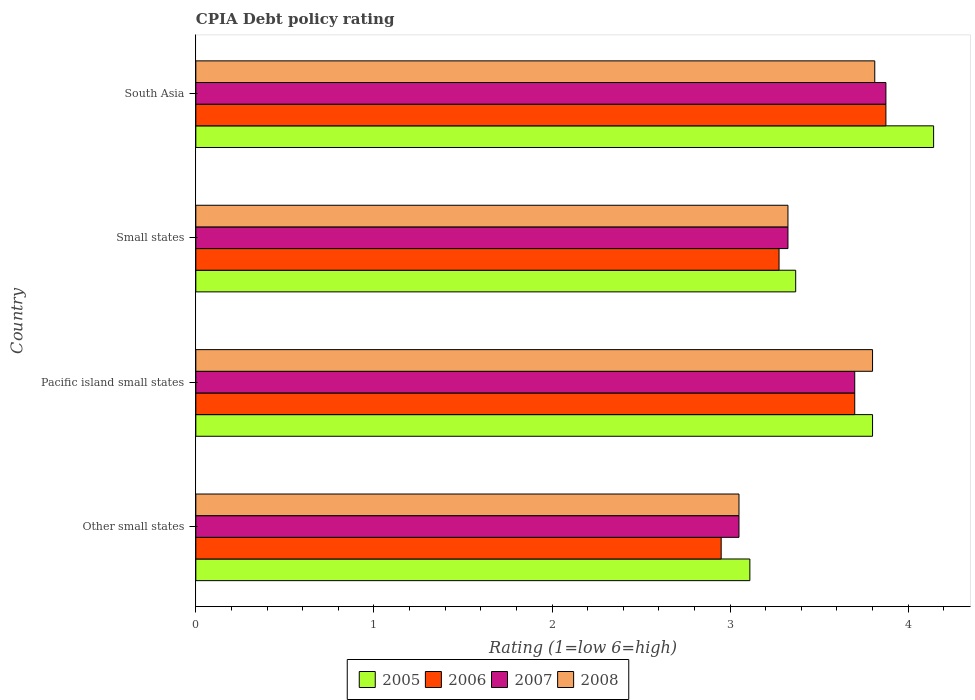How many different coloured bars are there?
Offer a very short reply. 4. How many groups of bars are there?
Your answer should be very brief. 4. Are the number of bars per tick equal to the number of legend labels?
Offer a very short reply. Yes. Are the number of bars on each tick of the Y-axis equal?
Keep it short and to the point. Yes. How many bars are there on the 2nd tick from the top?
Keep it short and to the point. 4. How many bars are there on the 2nd tick from the bottom?
Offer a very short reply. 4. What is the label of the 4th group of bars from the top?
Give a very brief answer. Other small states. In how many cases, is the number of bars for a given country not equal to the number of legend labels?
Your response must be concise. 0. What is the CPIA rating in 2008 in Small states?
Give a very brief answer. 3.33. Across all countries, what is the maximum CPIA rating in 2007?
Give a very brief answer. 3.88. Across all countries, what is the minimum CPIA rating in 2008?
Your response must be concise. 3.05. In which country was the CPIA rating in 2005 minimum?
Your answer should be very brief. Other small states. What is the difference between the CPIA rating in 2005 in Other small states and that in Pacific island small states?
Offer a terse response. -0.69. What is the difference between the CPIA rating in 2008 in Pacific island small states and the CPIA rating in 2005 in Small states?
Your answer should be compact. 0.43. What is the average CPIA rating in 2006 per country?
Offer a terse response. 3.45. What is the difference between the CPIA rating in 2005 and CPIA rating in 2006 in Pacific island small states?
Provide a short and direct response. 0.1. What is the ratio of the CPIA rating in 2007 in Other small states to that in Small states?
Provide a succinct answer. 0.92. Is the difference between the CPIA rating in 2005 in Small states and South Asia greater than the difference between the CPIA rating in 2006 in Small states and South Asia?
Your answer should be very brief. No. What is the difference between the highest and the second highest CPIA rating in 2008?
Offer a very short reply. 0.01. What is the difference between the highest and the lowest CPIA rating in 2007?
Your answer should be very brief. 0.83. What does the 2nd bar from the bottom in Pacific island small states represents?
Your response must be concise. 2006. What is the difference between two consecutive major ticks on the X-axis?
Offer a terse response. 1. Are the values on the major ticks of X-axis written in scientific E-notation?
Provide a short and direct response. No. Does the graph contain grids?
Your answer should be compact. No. How are the legend labels stacked?
Keep it short and to the point. Horizontal. What is the title of the graph?
Give a very brief answer. CPIA Debt policy rating. What is the label or title of the X-axis?
Your response must be concise. Rating (1=low 6=high). What is the label or title of the Y-axis?
Ensure brevity in your answer.  Country. What is the Rating (1=low 6=high) in 2005 in Other small states?
Your answer should be compact. 3.11. What is the Rating (1=low 6=high) of 2006 in Other small states?
Offer a very short reply. 2.95. What is the Rating (1=low 6=high) in 2007 in Other small states?
Make the answer very short. 3.05. What is the Rating (1=low 6=high) in 2008 in Other small states?
Offer a terse response. 3.05. What is the Rating (1=low 6=high) in 2006 in Pacific island small states?
Your answer should be compact. 3.7. What is the Rating (1=low 6=high) of 2008 in Pacific island small states?
Your answer should be very brief. 3.8. What is the Rating (1=low 6=high) in 2005 in Small states?
Provide a short and direct response. 3.37. What is the Rating (1=low 6=high) in 2006 in Small states?
Provide a succinct answer. 3.27. What is the Rating (1=low 6=high) of 2007 in Small states?
Make the answer very short. 3.33. What is the Rating (1=low 6=high) in 2008 in Small states?
Your response must be concise. 3.33. What is the Rating (1=low 6=high) in 2005 in South Asia?
Your response must be concise. 4.14. What is the Rating (1=low 6=high) of 2006 in South Asia?
Offer a very short reply. 3.88. What is the Rating (1=low 6=high) of 2007 in South Asia?
Offer a very short reply. 3.88. What is the Rating (1=low 6=high) in 2008 in South Asia?
Your answer should be compact. 3.81. Across all countries, what is the maximum Rating (1=low 6=high) in 2005?
Your answer should be compact. 4.14. Across all countries, what is the maximum Rating (1=low 6=high) of 2006?
Offer a very short reply. 3.88. Across all countries, what is the maximum Rating (1=low 6=high) of 2007?
Give a very brief answer. 3.88. Across all countries, what is the maximum Rating (1=low 6=high) of 2008?
Provide a succinct answer. 3.81. Across all countries, what is the minimum Rating (1=low 6=high) of 2005?
Your answer should be very brief. 3.11. Across all countries, what is the minimum Rating (1=low 6=high) in 2006?
Your answer should be very brief. 2.95. Across all countries, what is the minimum Rating (1=low 6=high) of 2007?
Provide a short and direct response. 3.05. Across all countries, what is the minimum Rating (1=low 6=high) of 2008?
Offer a very short reply. 3.05. What is the total Rating (1=low 6=high) in 2005 in the graph?
Offer a terse response. 14.42. What is the total Rating (1=low 6=high) of 2007 in the graph?
Give a very brief answer. 13.95. What is the total Rating (1=low 6=high) of 2008 in the graph?
Your answer should be very brief. 13.99. What is the difference between the Rating (1=low 6=high) in 2005 in Other small states and that in Pacific island small states?
Provide a short and direct response. -0.69. What is the difference between the Rating (1=low 6=high) of 2006 in Other small states and that in Pacific island small states?
Offer a very short reply. -0.75. What is the difference between the Rating (1=low 6=high) in 2007 in Other small states and that in Pacific island small states?
Your answer should be compact. -0.65. What is the difference between the Rating (1=low 6=high) in 2008 in Other small states and that in Pacific island small states?
Offer a very short reply. -0.75. What is the difference between the Rating (1=low 6=high) in 2005 in Other small states and that in Small states?
Keep it short and to the point. -0.26. What is the difference between the Rating (1=low 6=high) of 2006 in Other small states and that in Small states?
Offer a terse response. -0.33. What is the difference between the Rating (1=low 6=high) of 2007 in Other small states and that in Small states?
Provide a succinct answer. -0.28. What is the difference between the Rating (1=low 6=high) of 2008 in Other small states and that in Small states?
Your answer should be very brief. -0.28. What is the difference between the Rating (1=low 6=high) in 2005 in Other small states and that in South Asia?
Provide a succinct answer. -1.03. What is the difference between the Rating (1=low 6=high) in 2006 in Other small states and that in South Asia?
Offer a terse response. -0.93. What is the difference between the Rating (1=low 6=high) in 2007 in Other small states and that in South Asia?
Your answer should be compact. -0.82. What is the difference between the Rating (1=low 6=high) of 2008 in Other small states and that in South Asia?
Offer a very short reply. -0.76. What is the difference between the Rating (1=low 6=high) in 2005 in Pacific island small states and that in Small states?
Offer a terse response. 0.43. What is the difference between the Rating (1=low 6=high) of 2006 in Pacific island small states and that in Small states?
Make the answer very short. 0.42. What is the difference between the Rating (1=low 6=high) in 2008 in Pacific island small states and that in Small states?
Provide a short and direct response. 0.47. What is the difference between the Rating (1=low 6=high) in 2005 in Pacific island small states and that in South Asia?
Your answer should be compact. -0.34. What is the difference between the Rating (1=low 6=high) in 2006 in Pacific island small states and that in South Asia?
Ensure brevity in your answer.  -0.17. What is the difference between the Rating (1=low 6=high) of 2007 in Pacific island small states and that in South Asia?
Your answer should be compact. -0.17. What is the difference between the Rating (1=low 6=high) in 2008 in Pacific island small states and that in South Asia?
Offer a very short reply. -0.01. What is the difference between the Rating (1=low 6=high) in 2005 in Small states and that in South Asia?
Provide a short and direct response. -0.77. What is the difference between the Rating (1=low 6=high) of 2006 in Small states and that in South Asia?
Your answer should be very brief. -0.6. What is the difference between the Rating (1=low 6=high) of 2007 in Small states and that in South Asia?
Keep it short and to the point. -0.55. What is the difference between the Rating (1=low 6=high) in 2008 in Small states and that in South Asia?
Your answer should be compact. -0.49. What is the difference between the Rating (1=low 6=high) in 2005 in Other small states and the Rating (1=low 6=high) in 2006 in Pacific island small states?
Give a very brief answer. -0.59. What is the difference between the Rating (1=low 6=high) of 2005 in Other small states and the Rating (1=low 6=high) of 2007 in Pacific island small states?
Make the answer very short. -0.59. What is the difference between the Rating (1=low 6=high) in 2005 in Other small states and the Rating (1=low 6=high) in 2008 in Pacific island small states?
Your response must be concise. -0.69. What is the difference between the Rating (1=low 6=high) of 2006 in Other small states and the Rating (1=low 6=high) of 2007 in Pacific island small states?
Your response must be concise. -0.75. What is the difference between the Rating (1=low 6=high) in 2006 in Other small states and the Rating (1=low 6=high) in 2008 in Pacific island small states?
Provide a succinct answer. -0.85. What is the difference between the Rating (1=low 6=high) of 2007 in Other small states and the Rating (1=low 6=high) of 2008 in Pacific island small states?
Make the answer very short. -0.75. What is the difference between the Rating (1=low 6=high) of 2005 in Other small states and the Rating (1=low 6=high) of 2006 in Small states?
Give a very brief answer. -0.16. What is the difference between the Rating (1=low 6=high) of 2005 in Other small states and the Rating (1=low 6=high) of 2007 in Small states?
Your answer should be very brief. -0.21. What is the difference between the Rating (1=low 6=high) of 2005 in Other small states and the Rating (1=low 6=high) of 2008 in Small states?
Your answer should be compact. -0.21. What is the difference between the Rating (1=low 6=high) in 2006 in Other small states and the Rating (1=low 6=high) in 2007 in Small states?
Make the answer very short. -0.38. What is the difference between the Rating (1=low 6=high) in 2006 in Other small states and the Rating (1=low 6=high) in 2008 in Small states?
Offer a terse response. -0.38. What is the difference between the Rating (1=low 6=high) in 2007 in Other small states and the Rating (1=low 6=high) in 2008 in Small states?
Make the answer very short. -0.28. What is the difference between the Rating (1=low 6=high) of 2005 in Other small states and the Rating (1=low 6=high) of 2006 in South Asia?
Keep it short and to the point. -0.76. What is the difference between the Rating (1=low 6=high) in 2005 in Other small states and the Rating (1=low 6=high) in 2007 in South Asia?
Give a very brief answer. -0.76. What is the difference between the Rating (1=low 6=high) of 2005 in Other small states and the Rating (1=low 6=high) of 2008 in South Asia?
Your answer should be compact. -0.7. What is the difference between the Rating (1=low 6=high) of 2006 in Other small states and the Rating (1=low 6=high) of 2007 in South Asia?
Keep it short and to the point. -0.93. What is the difference between the Rating (1=low 6=high) of 2006 in Other small states and the Rating (1=low 6=high) of 2008 in South Asia?
Keep it short and to the point. -0.86. What is the difference between the Rating (1=low 6=high) in 2007 in Other small states and the Rating (1=low 6=high) in 2008 in South Asia?
Your answer should be compact. -0.76. What is the difference between the Rating (1=low 6=high) in 2005 in Pacific island small states and the Rating (1=low 6=high) in 2006 in Small states?
Give a very brief answer. 0.53. What is the difference between the Rating (1=low 6=high) of 2005 in Pacific island small states and the Rating (1=low 6=high) of 2007 in Small states?
Offer a terse response. 0.47. What is the difference between the Rating (1=low 6=high) of 2005 in Pacific island small states and the Rating (1=low 6=high) of 2008 in Small states?
Provide a succinct answer. 0.47. What is the difference between the Rating (1=low 6=high) of 2006 in Pacific island small states and the Rating (1=low 6=high) of 2007 in Small states?
Provide a short and direct response. 0.38. What is the difference between the Rating (1=low 6=high) of 2006 in Pacific island small states and the Rating (1=low 6=high) of 2008 in Small states?
Keep it short and to the point. 0.38. What is the difference between the Rating (1=low 6=high) in 2007 in Pacific island small states and the Rating (1=low 6=high) in 2008 in Small states?
Keep it short and to the point. 0.38. What is the difference between the Rating (1=low 6=high) in 2005 in Pacific island small states and the Rating (1=low 6=high) in 2006 in South Asia?
Offer a very short reply. -0.07. What is the difference between the Rating (1=low 6=high) of 2005 in Pacific island small states and the Rating (1=low 6=high) of 2007 in South Asia?
Your answer should be very brief. -0.07. What is the difference between the Rating (1=low 6=high) in 2005 in Pacific island small states and the Rating (1=low 6=high) in 2008 in South Asia?
Give a very brief answer. -0.01. What is the difference between the Rating (1=low 6=high) of 2006 in Pacific island small states and the Rating (1=low 6=high) of 2007 in South Asia?
Your answer should be compact. -0.17. What is the difference between the Rating (1=low 6=high) of 2006 in Pacific island small states and the Rating (1=low 6=high) of 2008 in South Asia?
Provide a short and direct response. -0.11. What is the difference between the Rating (1=low 6=high) of 2007 in Pacific island small states and the Rating (1=low 6=high) of 2008 in South Asia?
Offer a terse response. -0.11. What is the difference between the Rating (1=low 6=high) in 2005 in Small states and the Rating (1=low 6=high) in 2006 in South Asia?
Your answer should be very brief. -0.51. What is the difference between the Rating (1=low 6=high) of 2005 in Small states and the Rating (1=low 6=high) of 2007 in South Asia?
Your answer should be very brief. -0.51. What is the difference between the Rating (1=low 6=high) in 2005 in Small states and the Rating (1=low 6=high) in 2008 in South Asia?
Your answer should be very brief. -0.44. What is the difference between the Rating (1=low 6=high) in 2006 in Small states and the Rating (1=low 6=high) in 2008 in South Asia?
Offer a terse response. -0.54. What is the difference between the Rating (1=low 6=high) in 2007 in Small states and the Rating (1=low 6=high) in 2008 in South Asia?
Provide a short and direct response. -0.49. What is the average Rating (1=low 6=high) of 2005 per country?
Keep it short and to the point. 3.61. What is the average Rating (1=low 6=high) in 2006 per country?
Offer a terse response. 3.45. What is the average Rating (1=low 6=high) in 2007 per country?
Ensure brevity in your answer.  3.49. What is the average Rating (1=low 6=high) in 2008 per country?
Provide a succinct answer. 3.5. What is the difference between the Rating (1=low 6=high) in 2005 and Rating (1=low 6=high) in 2006 in Other small states?
Offer a very short reply. 0.16. What is the difference between the Rating (1=low 6=high) of 2005 and Rating (1=low 6=high) of 2007 in Other small states?
Your answer should be very brief. 0.06. What is the difference between the Rating (1=low 6=high) of 2005 and Rating (1=low 6=high) of 2008 in Other small states?
Make the answer very short. 0.06. What is the difference between the Rating (1=low 6=high) in 2006 and Rating (1=low 6=high) in 2008 in Other small states?
Keep it short and to the point. -0.1. What is the difference between the Rating (1=low 6=high) of 2007 and Rating (1=low 6=high) of 2008 in Other small states?
Ensure brevity in your answer.  0. What is the difference between the Rating (1=low 6=high) in 2005 and Rating (1=low 6=high) in 2008 in Pacific island small states?
Your response must be concise. 0. What is the difference between the Rating (1=low 6=high) in 2006 and Rating (1=low 6=high) in 2007 in Pacific island small states?
Your answer should be very brief. 0. What is the difference between the Rating (1=low 6=high) of 2007 and Rating (1=low 6=high) of 2008 in Pacific island small states?
Provide a short and direct response. -0.1. What is the difference between the Rating (1=low 6=high) in 2005 and Rating (1=low 6=high) in 2006 in Small states?
Provide a succinct answer. 0.09. What is the difference between the Rating (1=low 6=high) in 2005 and Rating (1=low 6=high) in 2007 in Small states?
Your response must be concise. 0.04. What is the difference between the Rating (1=low 6=high) in 2005 and Rating (1=low 6=high) in 2008 in Small states?
Give a very brief answer. 0.04. What is the difference between the Rating (1=low 6=high) of 2006 and Rating (1=low 6=high) of 2007 in Small states?
Give a very brief answer. -0.05. What is the difference between the Rating (1=low 6=high) of 2005 and Rating (1=low 6=high) of 2006 in South Asia?
Offer a very short reply. 0.27. What is the difference between the Rating (1=low 6=high) of 2005 and Rating (1=low 6=high) of 2007 in South Asia?
Ensure brevity in your answer.  0.27. What is the difference between the Rating (1=low 6=high) in 2005 and Rating (1=low 6=high) in 2008 in South Asia?
Your response must be concise. 0.33. What is the difference between the Rating (1=low 6=high) in 2006 and Rating (1=low 6=high) in 2007 in South Asia?
Your answer should be very brief. 0. What is the difference between the Rating (1=low 6=high) of 2006 and Rating (1=low 6=high) of 2008 in South Asia?
Ensure brevity in your answer.  0.06. What is the difference between the Rating (1=low 6=high) of 2007 and Rating (1=low 6=high) of 2008 in South Asia?
Provide a succinct answer. 0.06. What is the ratio of the Rating (1=low 6=high) in 2005 in Other small states to that in Pacific island small states?
Provide a short and direct response. 0.82. What is the ratio of the Rating (1=low 6=high) of 2006 in Other small states to that in Pacific island small states?
Your response must be concise. 0.8. What is the ratio of the Rating (1=low 6=high) of 2007 in Other small states to that in Pacific island small states?
Your answer should be very brief. 0.82. What is the ratio of the Rating (1=low 6=high) of 2008 in Other small states to that in Pacific island small states?
Your answer should be very brief. 0.8. What is the ratio of the Rating (1=low 6=high) of 2005 in Other small states to that in Small states?
Provide a succinct answer. 0.92. What is the ratio of the Rating (1=low 6=high) of 2006 in Other small states to that in Small states?
Offer a terse response. 0.9. What is the ratio of the Rating (1=low 6=high) of 2007 in Other small states to that in Small states?
Your answer should be compact. 0.92. What is the ratio of the Rating (1=low 6=high) of 2008 in Other small states to that in Small states?
Offer a terse response. 0.92. What is the ratio of the Rating (1=low 6=high) in 2005 in Other small states to that in South Asia?
Give a very brief answer. 0.75. What is the ratio of the Rating (1=low 6=high) in 2006 in Other small states to that in South Asia?
Give a very brief answer. 0.76. What is the ratio of the Rating (1=low 6=high) in 2007 in Other small states to that in South Asia?
Provide a short and direct response. 0.79. What is the ratio of the Rating (1=low 6=high) in 2008 in Other small states to that in South Asia?
Ensure brevity in your answer.  0.8. What is the ratio of the Rating (1=low 6=high) in 2005 in Pacific island small states to that in Small states?
Keep it short and to the point. 1.13. What is the ratio of the Rating (1=low 6=high) in 2006 in Pacific island small states to that in Small states?
Provide a short and direct response. 1.13. What is the ratio of the Rating (1=low 6=high) of 2007 in Pacific island small states to that in Small states?
Ensure brevity in your answer.  1.11. What is the ratio of the Rating (1=low 6=high) in 2005 in Pacific island small states to that in South Asia?
Offer a terse response. 0.92. What is the ratio of the Rating (1=low 6=high) in 2006 in Pacific island small states to that in South Asia?
Make the answer very short. 0.95. What is the ratio of the Rating (1=low 6=high) of 2007 in Pacific island small states to that in South Asia?
Ensure brevity in your answer.  0.95. What is the ratio of the Rating (1=low 6=high) in 2008 in Pacific island small states to that in South Asia?
Make the answer very short. 1. What is the ratio of the Rating (1=low 6=high) of 2005 in Small states to that in South Asia?
Your answer should be very brief. 0.81. What is the ratio of the Rating (1=low 6=high) in 2006 in Small states to that in South Asia?
Offer a terse response. 0.85. What is the ratio of the Rating (1=low 6=high) of 2007 in Small states to that in South Asia?
Ensure brevity in your answer.  0.86. What is the ratio of the Rating (1=low 6=high) in 2008 in Small states to that in South Asia?
Your response must be concise. 0.87. What is the difference between the highest and the second highest Rating (1=low 6=high) of 2005?
Your response must be concise. 0.34. What is the difference between the highest and the second highest Rating (1=low 6=high) in 2006?
Keep it short and to the point. 0.17. What is the difference between the highest and the second highest Rating (1=low 6=high) of 2007?
Offer a terse response. 0.17. What is the difference between the highest and the second highest Rating (1=low 6=high) in 2008?
Your response must be concise. 0.01. What is the difference between the highest and the lowest Rating (1=low 6=high) in 2005?
Make the answer very short. 1.03. What is the difference between the highest and the lowest Rating (1=low 6=high) in 2006?
Give a very brief answer. 0.93. What is the difference between the highest and the lowest Rating (1=low 6=high) in 2007?
Offer a very short reply. 0.82. What is the difference between the highest and the lowest Rating (1=low 6=high) in 2008?
Ensure brevity in your answer.  0.76. 